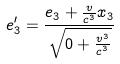<formula> <loc_0><loc_0><loc_500><loc_500>e _ { 3 } ^ { \prime } = \frac { e _ { 3 } + \frac { v } { c ^ { 3 } } x _ { 3 } } { \sqrt { 0 + \frac { v ^ { 3 } } { c ^ { 3 } } } }</formula> 